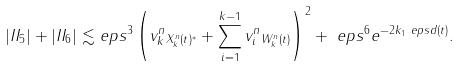<formula> <loc_0><loc_0><loc_500><loc_500>| I I _ { 5 } | + | I I _ { 6 } | \lesssim & \ e p s ^ { 3 } \left ( \| v _ { k } ^ { n } \| _ { X _ { k } ^ { n } ( t ) ^ { * } } + \sum _ { i = 1 } ^ { k - 1 } \| v _ { i } ^ { n } \| _ { W _ { k } ^ { n } ( t ) } \right ) ^ { 2 } + \ e p s ^ { 6 } e ^ { - 2 k _ { 1 } \ e p s d ( t ) } .</formula> 